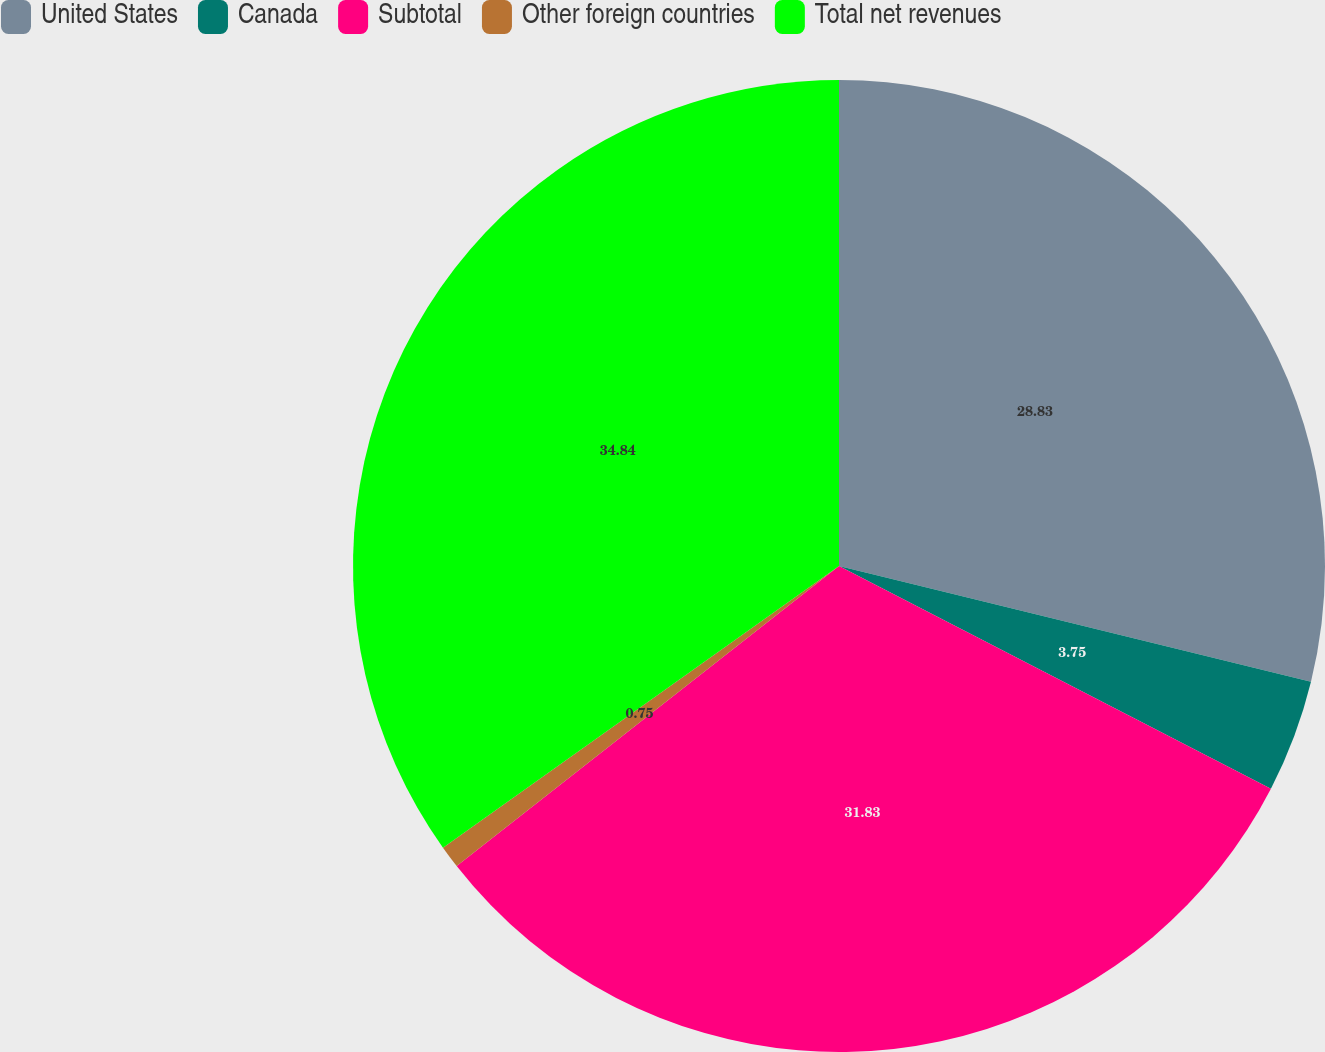Convert chart to OTSL. <chart><loc_0><loc_0><loc_500><loc_500><pie_chart><fcel>United States<fcel>Canada<fcel>Subtotal<fcel>Other foreign countries<fcel>Total net revenues<nl><fcel>28.83%<fcel>3.75%<fcel>31.83%<fcel>0.75%<fcel>34.84%<nl></chart> 